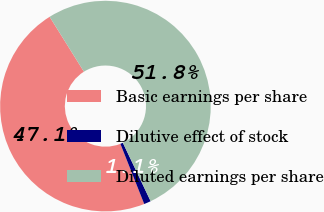Convert chart to OTSL. <chart><loc_0><loc_0><loc_500><loc_500><pie_chart><fcel>Basic earnings per share<fcel>Dilutive effect of stock<fcel>Diluted earnings per share<nl><fcel>47.12%<fcel>1.06%<fcel>51.83%<nl></chart> 